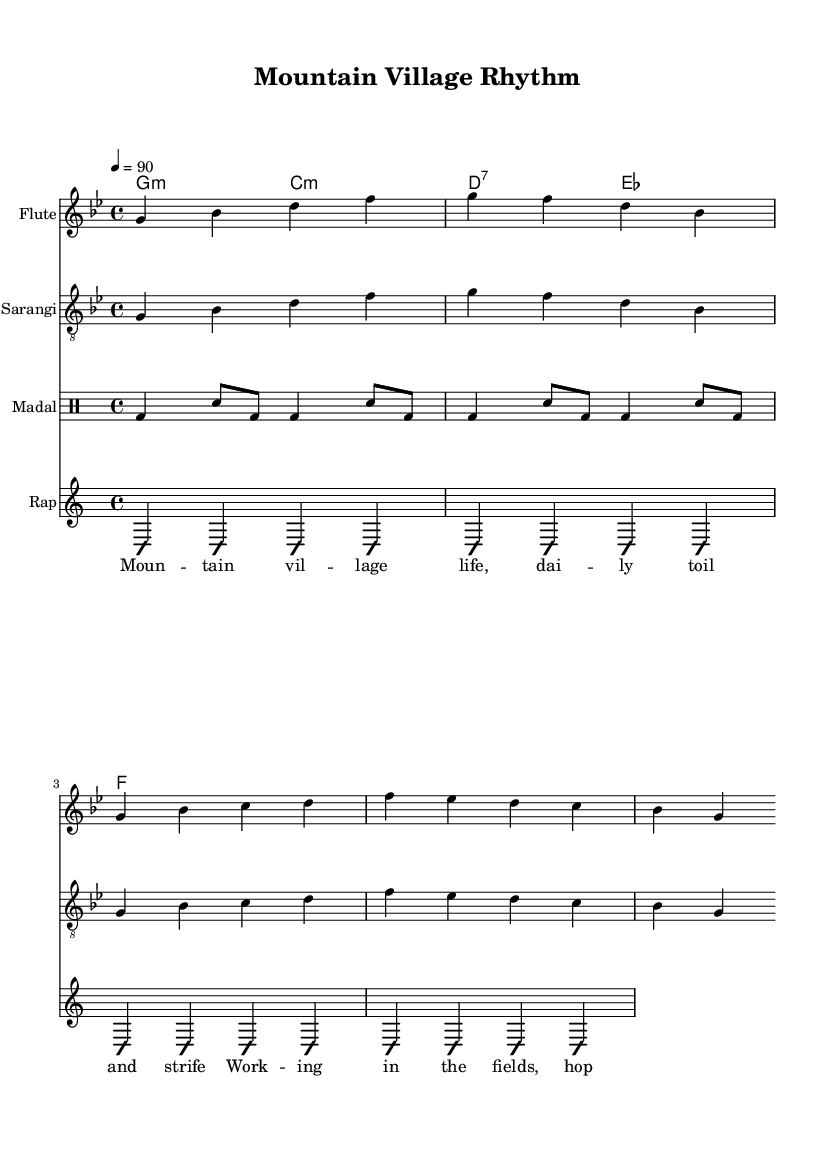What is the key signature of this music? The key signature is G minor, indicated by the one flat (B♭) in the key signature area of the sheet music.
Answer: G minor What is the time signature of the piece? The time signature is 4/4, which means there are four beats in each measure and the quarter note receives one beat, as shown at the beginning of the score.
Answer: 4/4 What is the tempo marked in the score? The tempo is marked as 90 beats per minute, shown above in the tempo indication at the beginning of the global section.
Answer: 90 Which instruments are represented in the score? The instruments represented are Flute, Sarangi, and Madal, indicated by the instrument names in the staff sections of the score.
Answer: Flute, Sarangi, Madal What kind of rhythmic pattern is used for the Madal? The rhythmic pattern used for the Madal is a double beat and snare combination, as notated in the drumming section, indicating the specific drumming rhythm.
Answer: bd4 sn8 How many measures are in the vocal section? The vocal section consists of four measures, as defined by the four groups of notes in the rap vocals part, correlating with the lyrics beneath it.
Answer: 4 What thematic elements can be inferred from the lyrics in the rap? The lyrics reflect themes of daily labor, hope for good harvests, and the struggles faced by the villagers, as indicated in the text of the rap vocals.
Answer: Daily toil and strife 